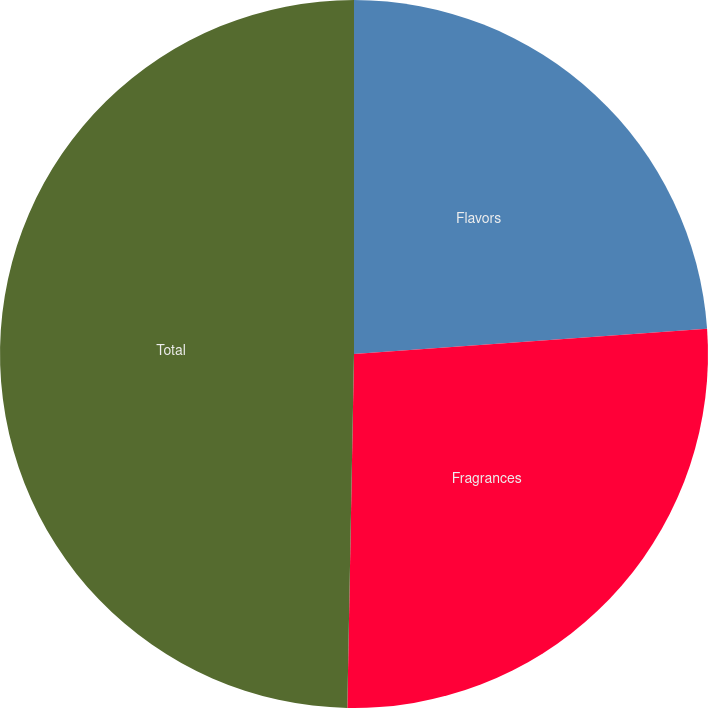<chart> <loc_0><loc_0><loc_500><loc_500><pie_chart><fcel>Flavors<fcel>Fragrances<fcel>Total<nl><fcel>23.86%<fcel>26.44%<fcel>49.7%<nl></chart> 